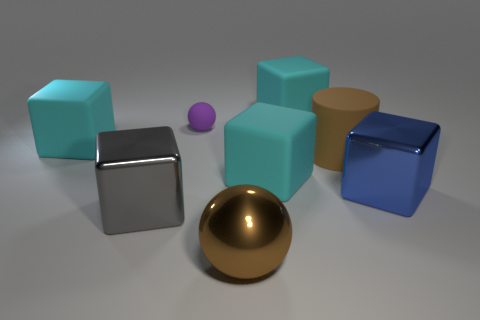How many cyan blocks must be subtracted to get 1 cyan blocks? 2 Subtract all purple balls. How many cyan cubes are left? 3 Subtract 1 cubes. How many cubes are left? 4 Subtract all gray blocks. How many blocks are left? 4 Subtract all big blue metallic blocks. How many blocks are left? 4 Subtract all yellow cubes. Subtract all brown balls. How many cubes are left? 5 Add 2 small purple things. How many objects exist? 10 Subtract all cubes. How many objects are left? 3 Add 4 big brown balls. How many big brown balls are left? 5 Add 2 tiny red matte things. How many tiny red matte things exist? 2 